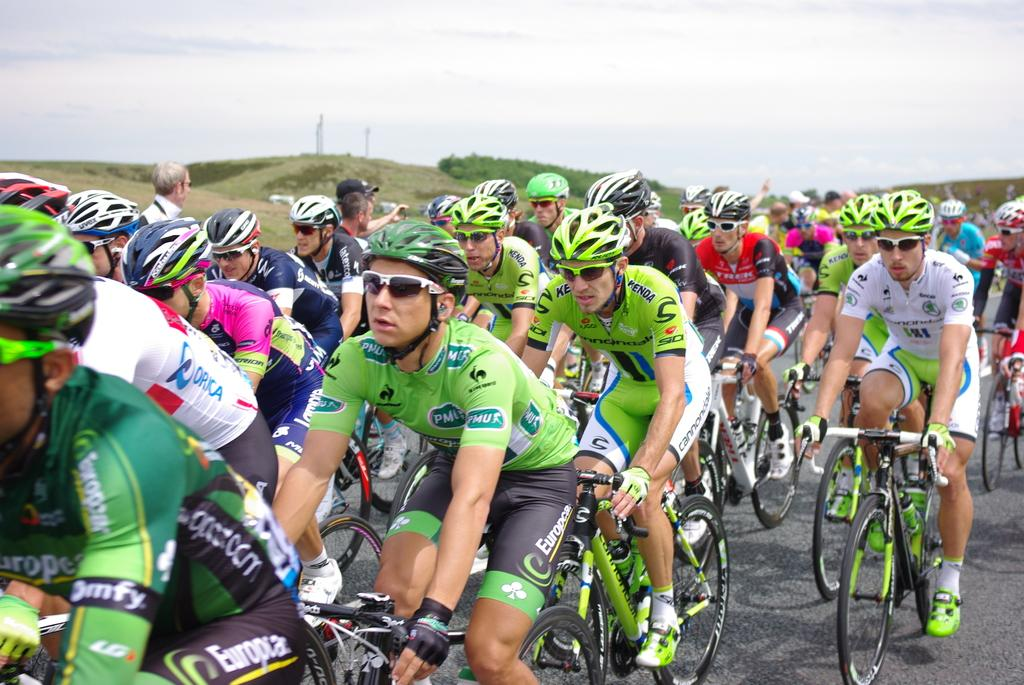What are the persons in the image doing? The persons in the image are riding bicycles. Where are the bicycles located? The bicycles are on a road. What can be seen in the background of the image? There is sky visible in the background of the image, with clouds present. What type of landscape feature is visible in the background? There are hills in the background of the image. What type of salt is being used to process the bicycles in the image? There is no salt or processing of bicycles present in the image; the persons are simply riding bicycles on a road. 